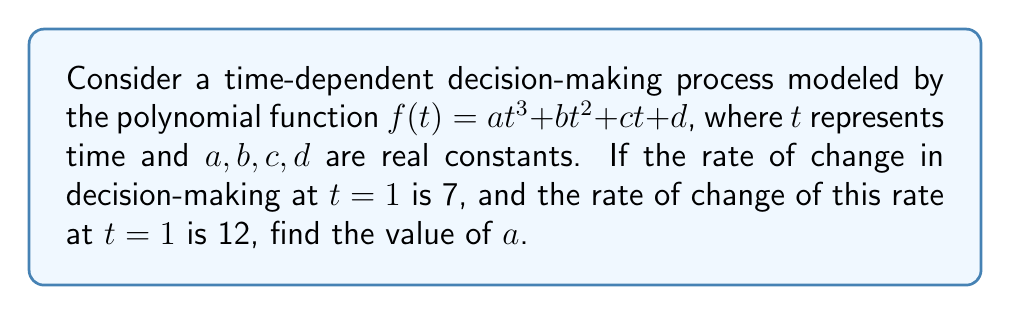Can you solve this math problem? To solve this problem, we'll follow these steps:

1) The rate of change in decision-making is represented by the first derivative of $f(t)$:
   $$f'(t) = 3at^2 + 2bt + c$$

2) The rate of change of this rate is the second derivative:
   $$f''(t) = 6at + 2b$$

3) We're given that at $t=1$, the rate of change is 7. This means:
   $$f'(1) = 3a + 2b + c = 7 \quad (1)$$

4) We're also told that at $t=1$, the rate of change of the rate is 12:
   $$f''(1) = 6a + 2b = 12 \quad (2)$$

5) From equation (2), we can express $b$ in terms of $a$:
   $$b = 6 - 3a \quad (3)$$

6) Substituting this into equation (1):
   $$3a + 2(6-3a) + c = 7$$
   $$3a + 12 - 6a + c = 7$$
   $$-3a + c = -5 \quad (4)$$

7) While we could solve for $c$ in terms of $a$, we don't need to. The question only asks for the value of $a$, and we have enough information from equation (2) alone.

8) Substituting (3) into (2):
   $$6a + 2(6-3a) = 12$$
   $$6a + 12 - 6a = 12$$
   $$12 = 12$$

9) This identity is true for any value of $a$, which means the value of $a$ is determined by the initial conditions of the function $f(t)$, not by the given rates of change.

Therefore, we cannot determine a unique value for $a$ based on the given information.
Answer: Indeterminate 